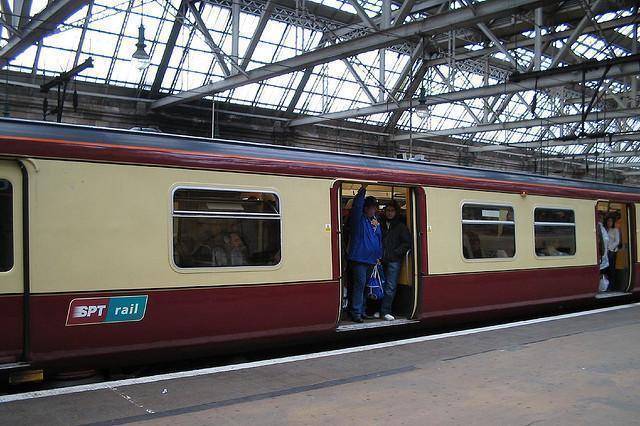What is the person wearing the blue coat about to do?
From the following set of four choices, select the accurate answer to respond to the question.
Options: Board train, wave goodbye, serve lunch, get off. Get off. 